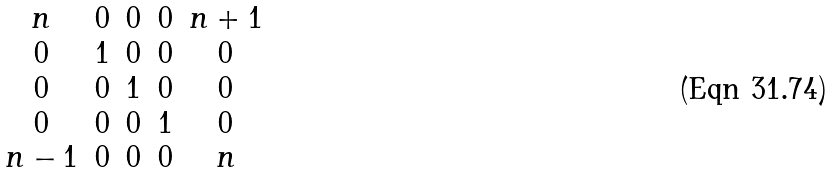<formula> <loc_0><loc_0><loc_500><loc_500>\begin{matrix} n & 0 & 0 & 0 & n + 1 \\ 0 & 1 & 0 & 0 & 0 \\ 0 & 0 & 1 & 0 & 0 \\ 0 & 0 & 0 & 1 & 0 \\ n - 1 & 0 & 0 & 0 & n \end{matrix}</formula> 